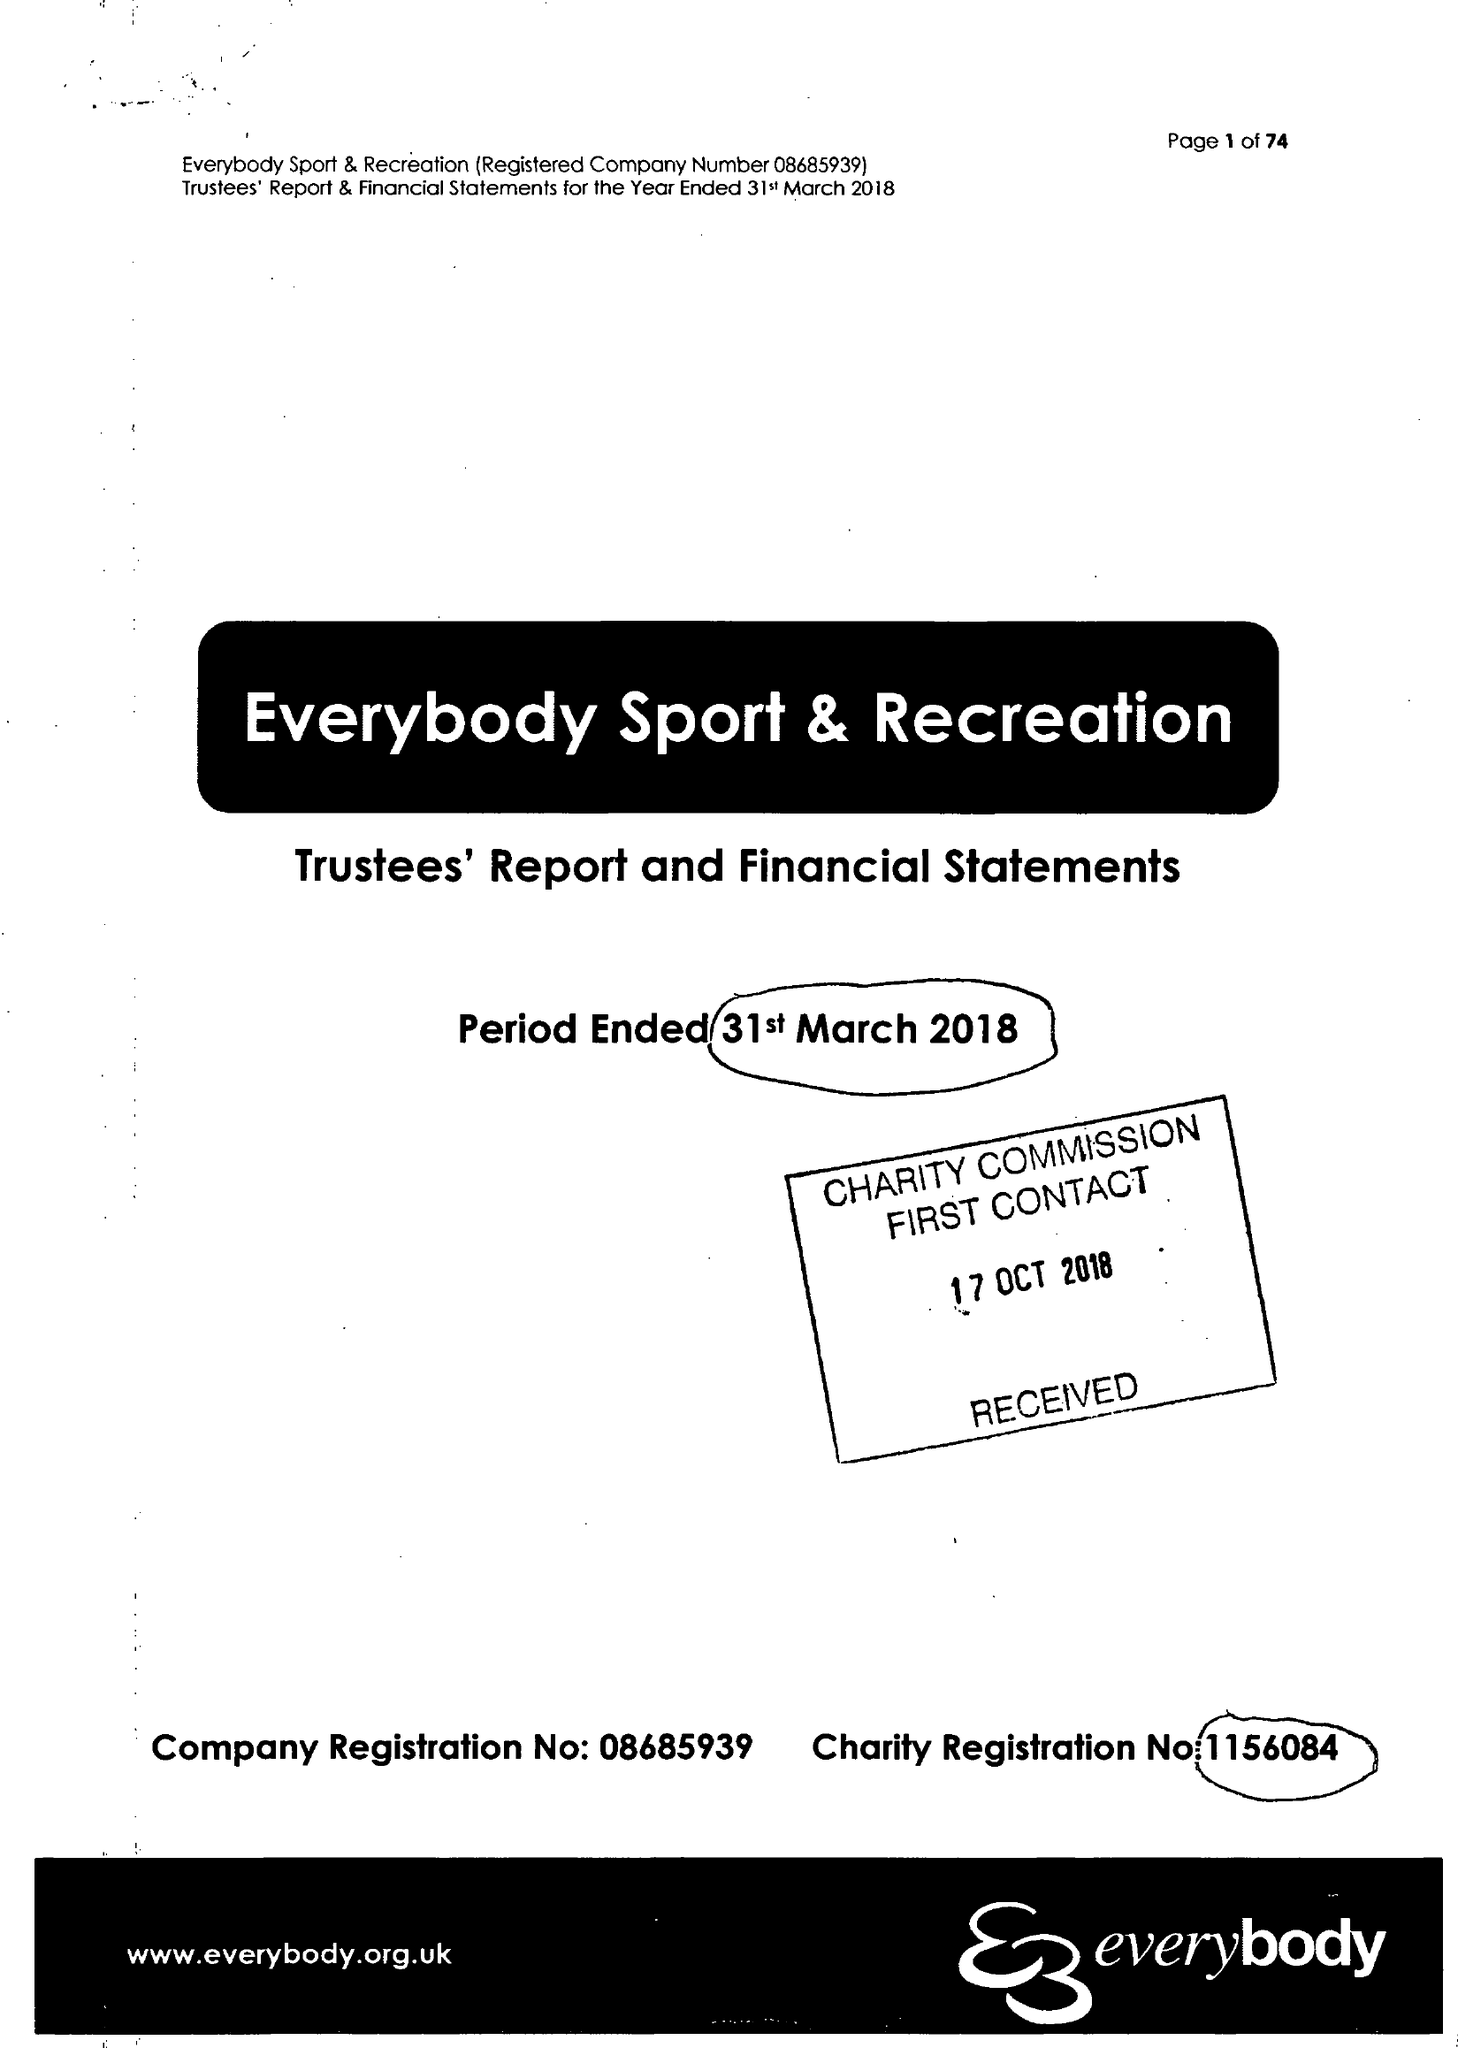What is the value for the charity_number?
Answer the question using a single word or phrase. 1156084 